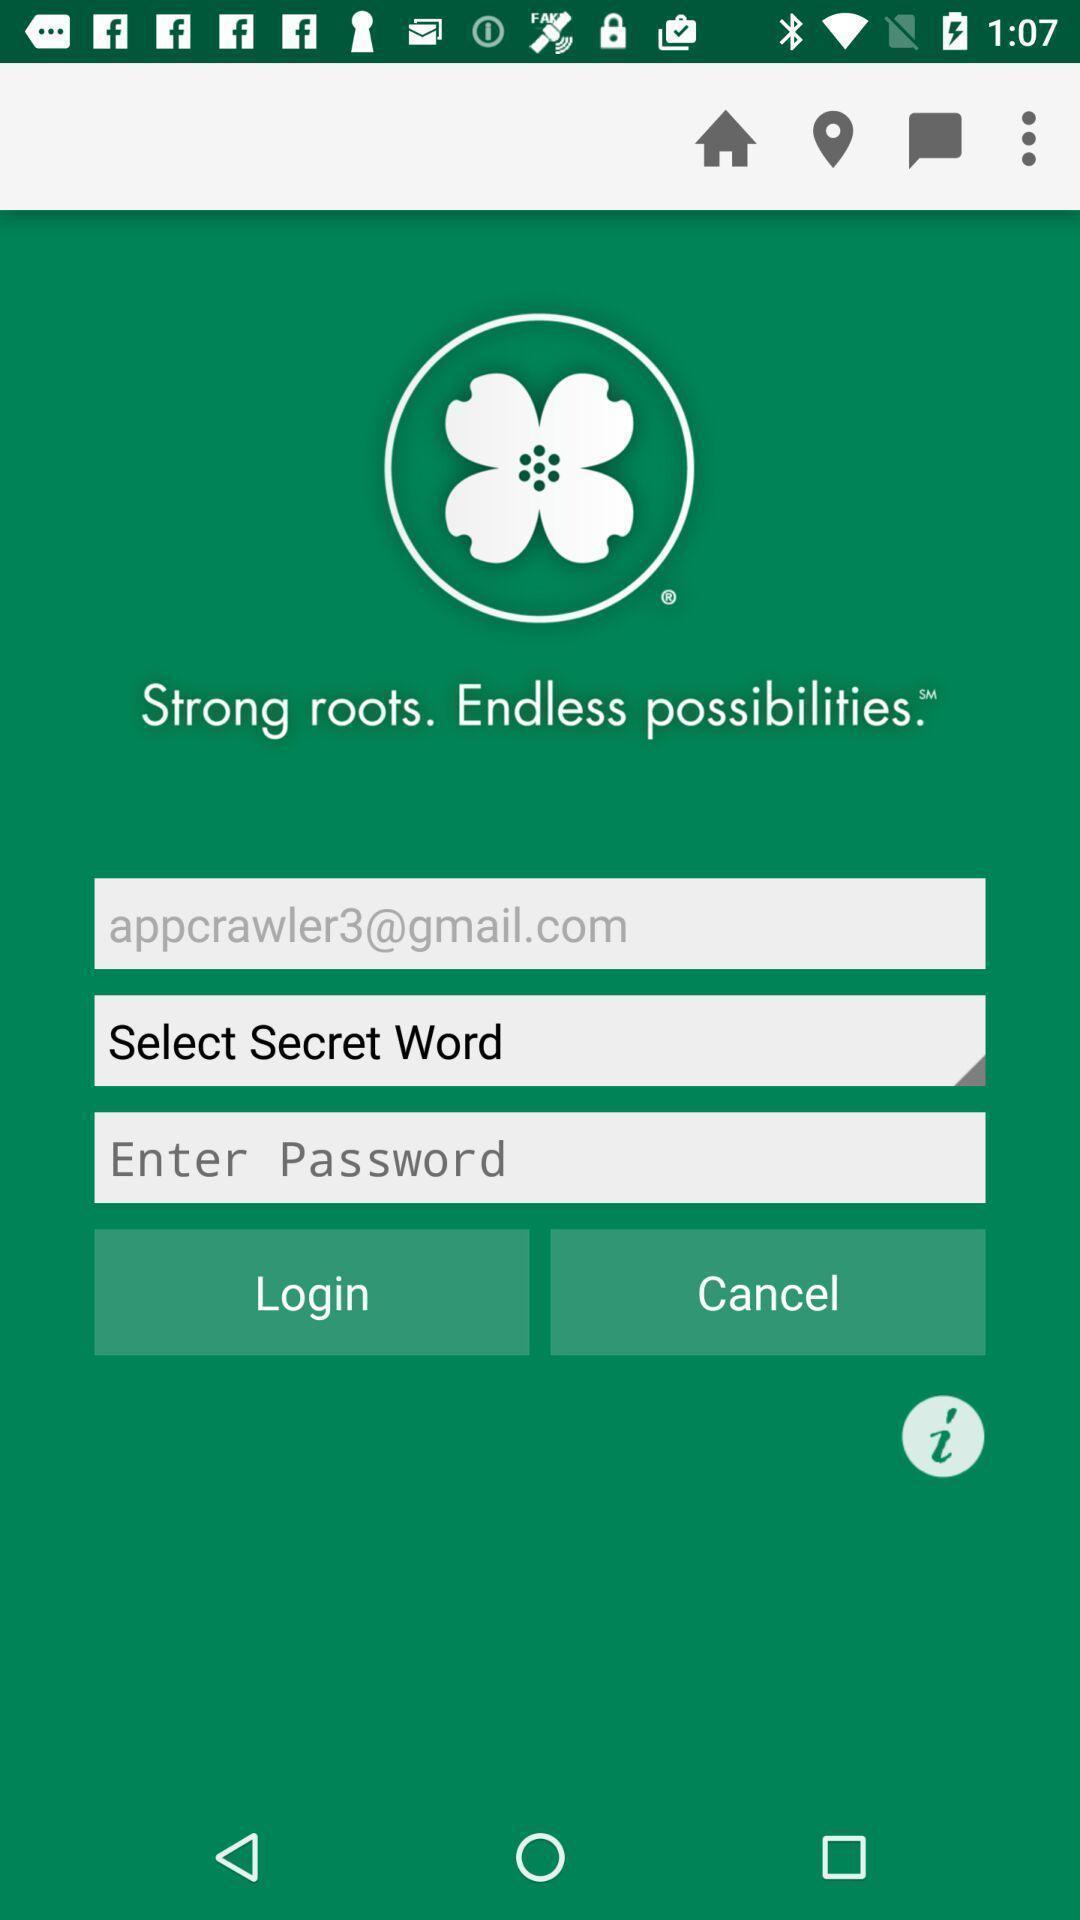Describe the content in this image. Login page with few options in banking app. 